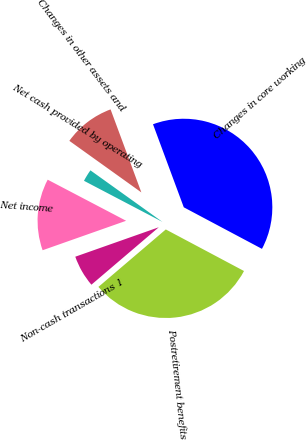<chart> <loc_0><loc_0><loc_500><loc_500><pie_chart><fcel>Net income<fcel>Non-cash transactions 1<fcel>Postretirement benefits<fcel>Changes in core working<fcel>Changes in other assets and<fcel>Net cash provided by operating<nl><fcel>13.08%<fcel>5.84%<fcel>30.99%<fcel>38.43%<fcel>9.46%<fcel>2.21%<nl></chart> 